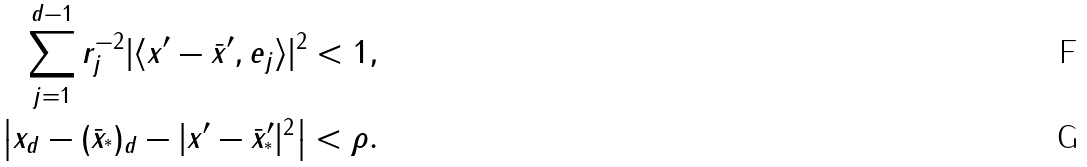Convert formula to latex. <formula><loc_0><loc_0><loc_500><loc_500>\sum _ { j = 1 } ^ { d - 1 } r _ { j } ^ { - 2 } | \langle x ^ { \prime } - \bar { x } ^ { \prime } , e _ { j } \rangle | ^ { 2 } < 1 , \\ \left | x _ { d } - ( \bar { x } _ { ^ { * } } ) _ { d } - | x ^ { \prime } - \bar { x } _ { ^ { * } } ^ { \prime } | ^ { 2 } \right | < \rho .</formula> 